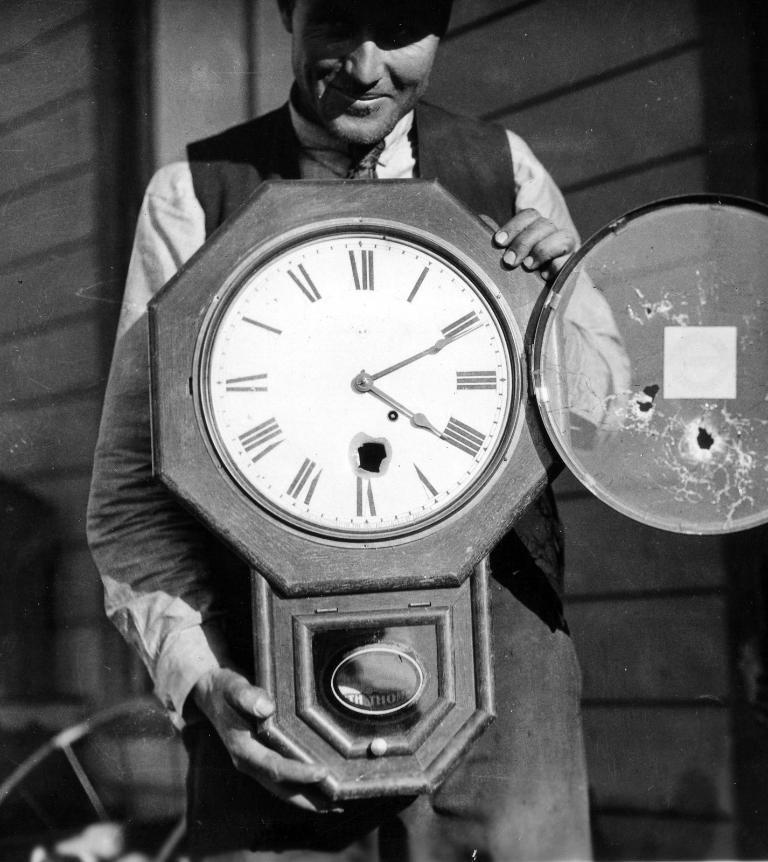<image>
Write a terse but informative summary of the picture. A man is holding a clock that says it is 4:10. 